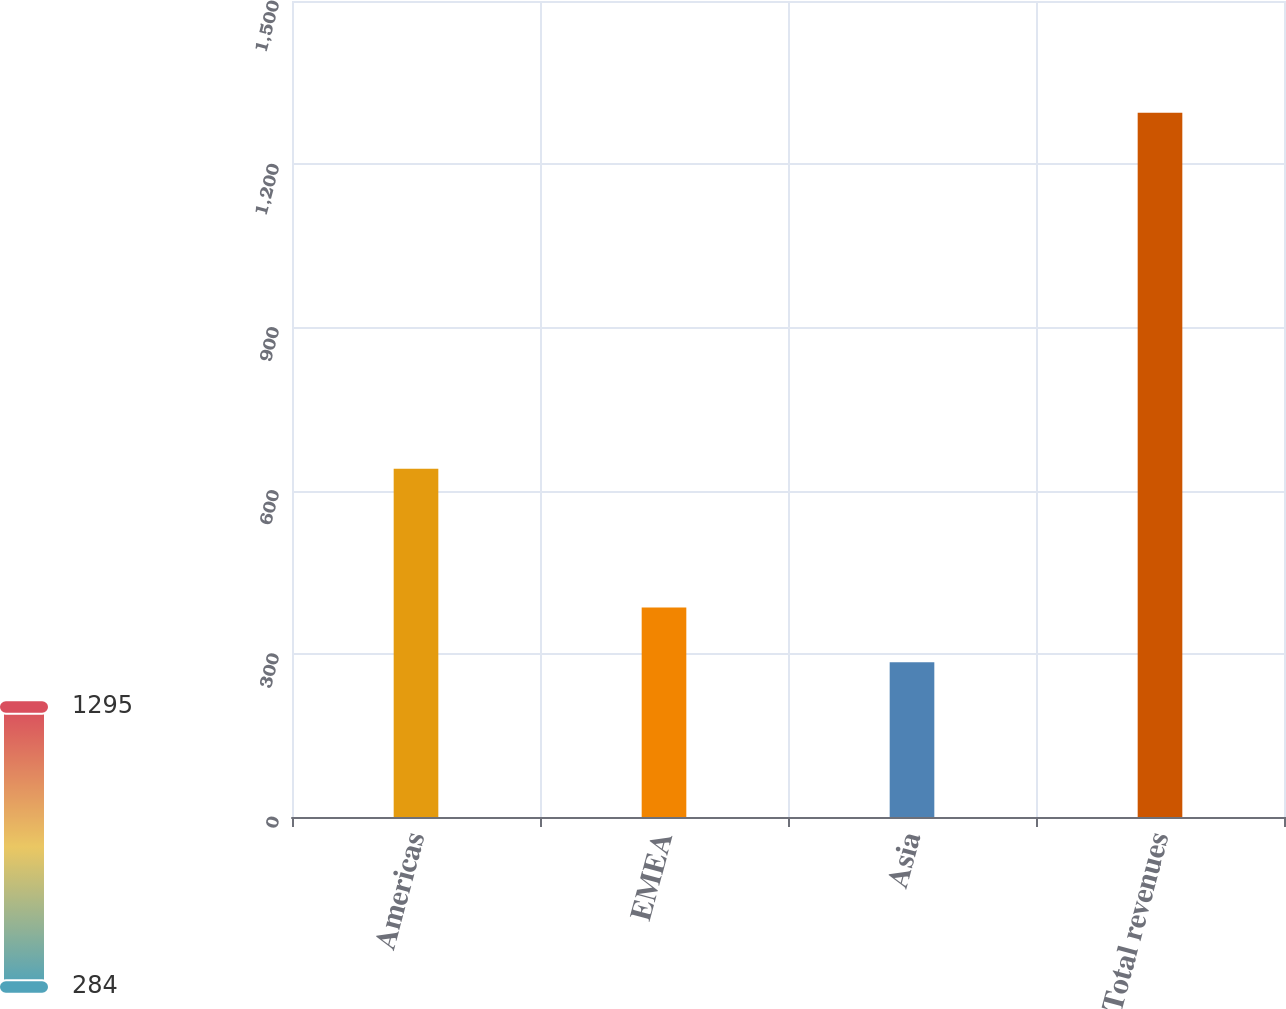Convert chart. <chart><loc_0><loc_0><loc_500><loc_500><bar_chart><fcel>Americas<fcel>EMEA<fcel>Asia<fcel>Total revenues<nl><fcel>640.2<fcel>385.34<fcel>284.3<fcel>1294.7<nl></chart> 